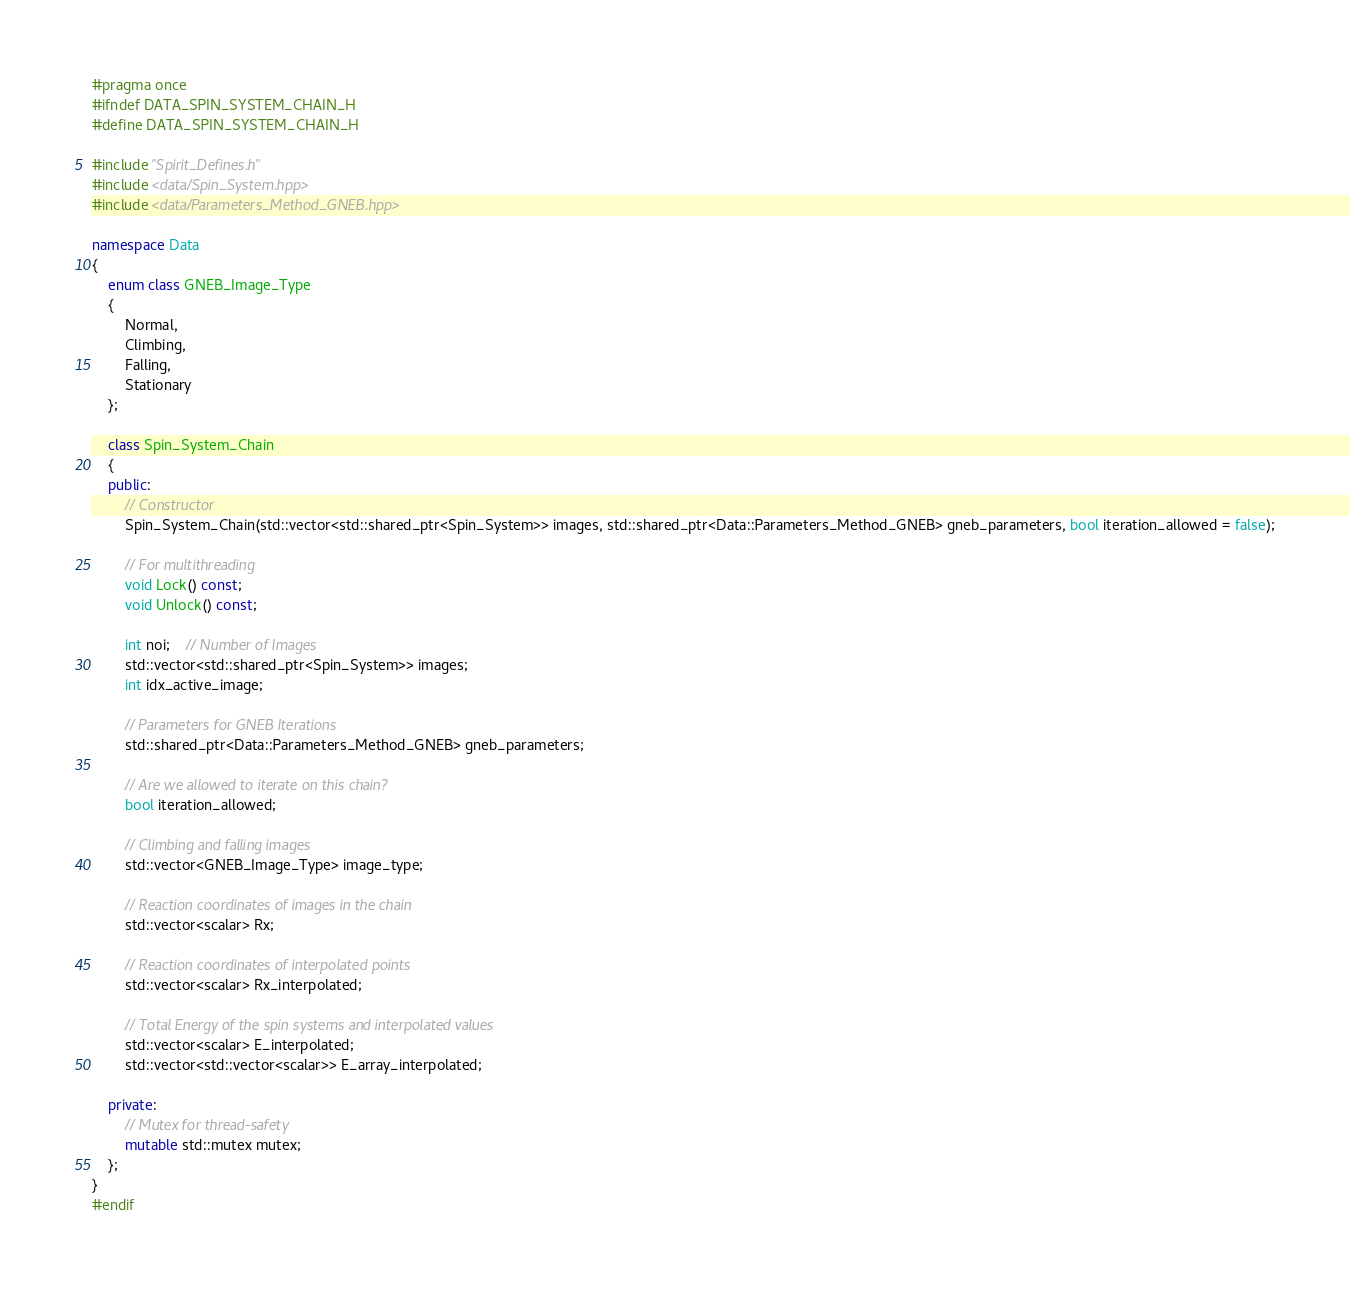<code> <loc_0><loc_0><loc_500><loc_500><_C++_>#pragma once
#ifndef DATA_SPIN_SYSTEM_CHAIN_H
#define DATA_SPIN_SYSTEM_CHAIN_H

#include "Spirit_Defines.h"
#include <data/Spin_System.hpp>
#include <data/Parameters_Method_GNEB.hpp>

namespace Data
{
	enum class GNEB_Image_Type
	{
		Normal,
		Climbing,
		Falling,
		Stationary
	};

	class Spin_System_Chain
	{
	public:
		// Constructor
		Spin_System_Chain(std::vector<std::shared_ptr<Spin_System>> images, std::shared_ptr<Data::Parameters_Method_GNEB> gneb_parameters, bool iteration_allowed = false);

		// For multithreading
		void Lock() const;
		void Unlock() const;

		int noi;	// Number of Images
		std::vector<std::shared_ptr<Spin_System>> images;
		int idx_active_image;

		// Parameters for GNEB Iterations
		std::shared_ptr<Data::Parameters_Method_GNEB> gneb_parameters;

		// Are we allowed to iterate on this chain?
		bool iteration_allowed;

		// Climbing and falling images
		std::vector<GNEB_Image_Type> image_type;

		// Reaction coordinates of images in the chain
		std::vector<scalar> Rx;

		// Reaction coordinates of interpolated points
		std::vector<scalar> Rx_interpolated;

		// Total Energy of the spin systems and interpolated values
		std::vector<scalar> E_interpolated;
		std::vector<std::vector<scalar>> E_array_interpolated;

	private:
		// Mutex for thread-safety
		mutable std::mutex mutex;
	};
}
#endif</code> 